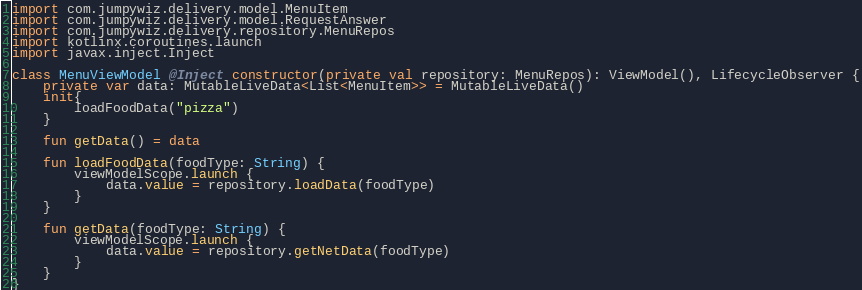Convert code to text. <code><loc_0><loc_0><loc_500><loc_500><_Kotlin_>import com.jumpywiz.delivery.model.MenuItem
import com.jumpywiz.delivery.model.RequestAnswer
import com.jumpywiz.delivery.repository.MenuRepos
import kotlinx.coroutines.launch
import javax.inject.Inject

class MenuViewModel @Inject constructor(private val repository: MenuRepos): ViewModel(), LifecycleObserver {
    private var data: MutableLiveData<List<MenuItem>> = MutableLiveData()
    init{
        loadFoodData("pizza")
    }

    fun getData() = data

    fun loadFoodData(foodType: String) {
        viewModelScope.launch {
            data.value = repository.loadData(foodType)
        }
    }

    fun getData(foodType: String) {
        viewModelScope.launch {
            data.value = repository.getNetData(foodType)
        }
    }
}</code> 